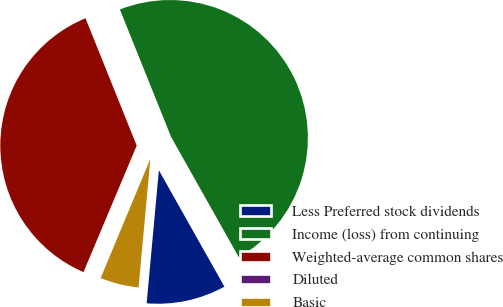Convert chart. <chart><loc_0><loc_0><loc_500><loc_500><pie_chart><fcel>Less Preferred stock dividends<fcel>Income (loss) from continuing<fcel>Weighted-average common shares<fcel>Diluted<fcel>Basic<nl><fcel>9.62%<fcel>47.92%<fcel>37.58%<fcel>0.05%<fcel>4.83%<nl></chart> 